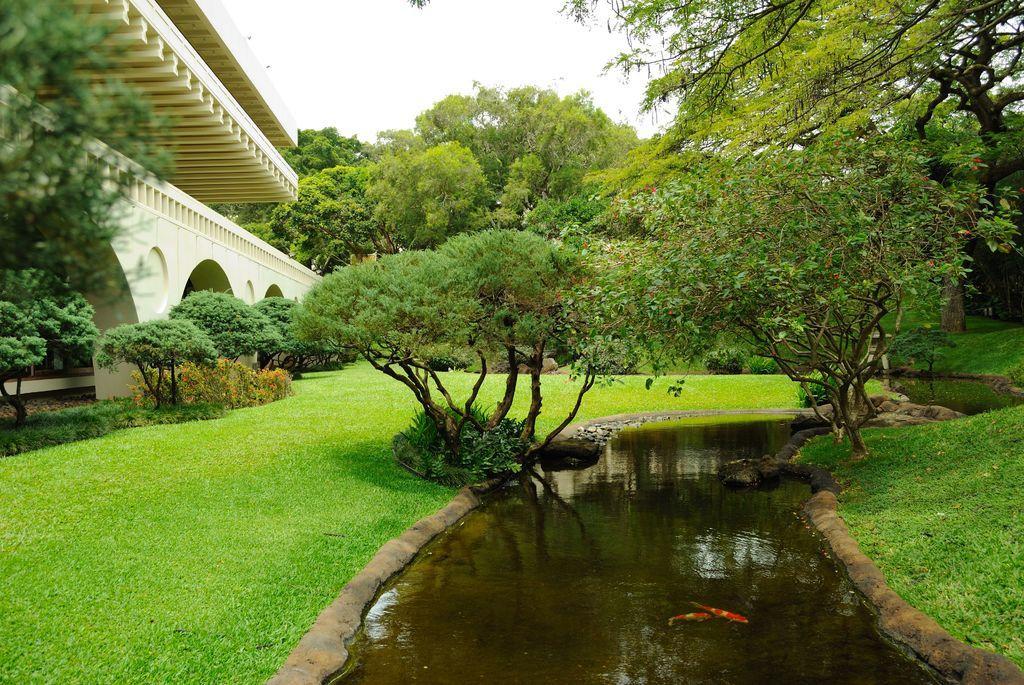How would you summarize this image in a sentence or two? In this picture I can see fish in the water. I can see a building, plants, trees, and in the background there is the sky. 